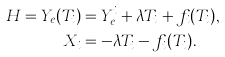<formula> <loc_0><loc_0><loc_500><loc_500>H = Y _ { e } ( T _ { i } ) & = Y _ { e } ^ { i } + \lambda T _ { i } + f _ { i } ( T _ { i } ) , \\ X _ { i } & = - \lambda T _ { i } - f _ { i } ( T _ { i } ) .</formula> 